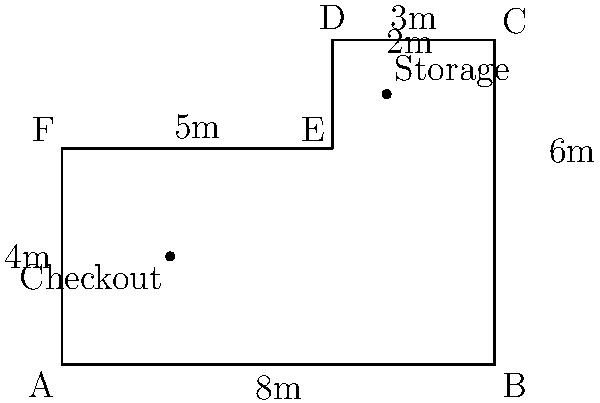As a franchise owner looking to maximize store layout efficiency, you're redesigning your store floor plan. The store has an irregular hexagonal shape as shown in the diagram. The main sales floor excludes the checkout area (2m x 2m) and storage area (2m x 1m). What is the maximum area (in square meters) available for product displays and customer movement? To solve this problem, we'll follow these steps:

1) Calculate the total area of the hexagonal store:
   The store can be divided into a rectangle (8m x 4m) and a rectangle (3m x 2m).
   Area = $(8 \times 4) + (3 \times 2) = 32 + 6 = 38$ sq m

2) Calculate the area of the checkout space:
   Checkout area = $2 \times 2 = 4$ sq m

3) Calculate the area of the storage space:
   Storage area = $2 \times 1 = 2$ sq m

4) Subtract the checkout and storage areas from the total area:
   Available area = Total area - (Checkout area + Storage area)
   Available area = $38 - (4 + 2) = 38 - 6 = 32$ sq m

Therefore, the maximum area available for product displays and customer movement is 32 square meters.
Answer: 32 sq m 